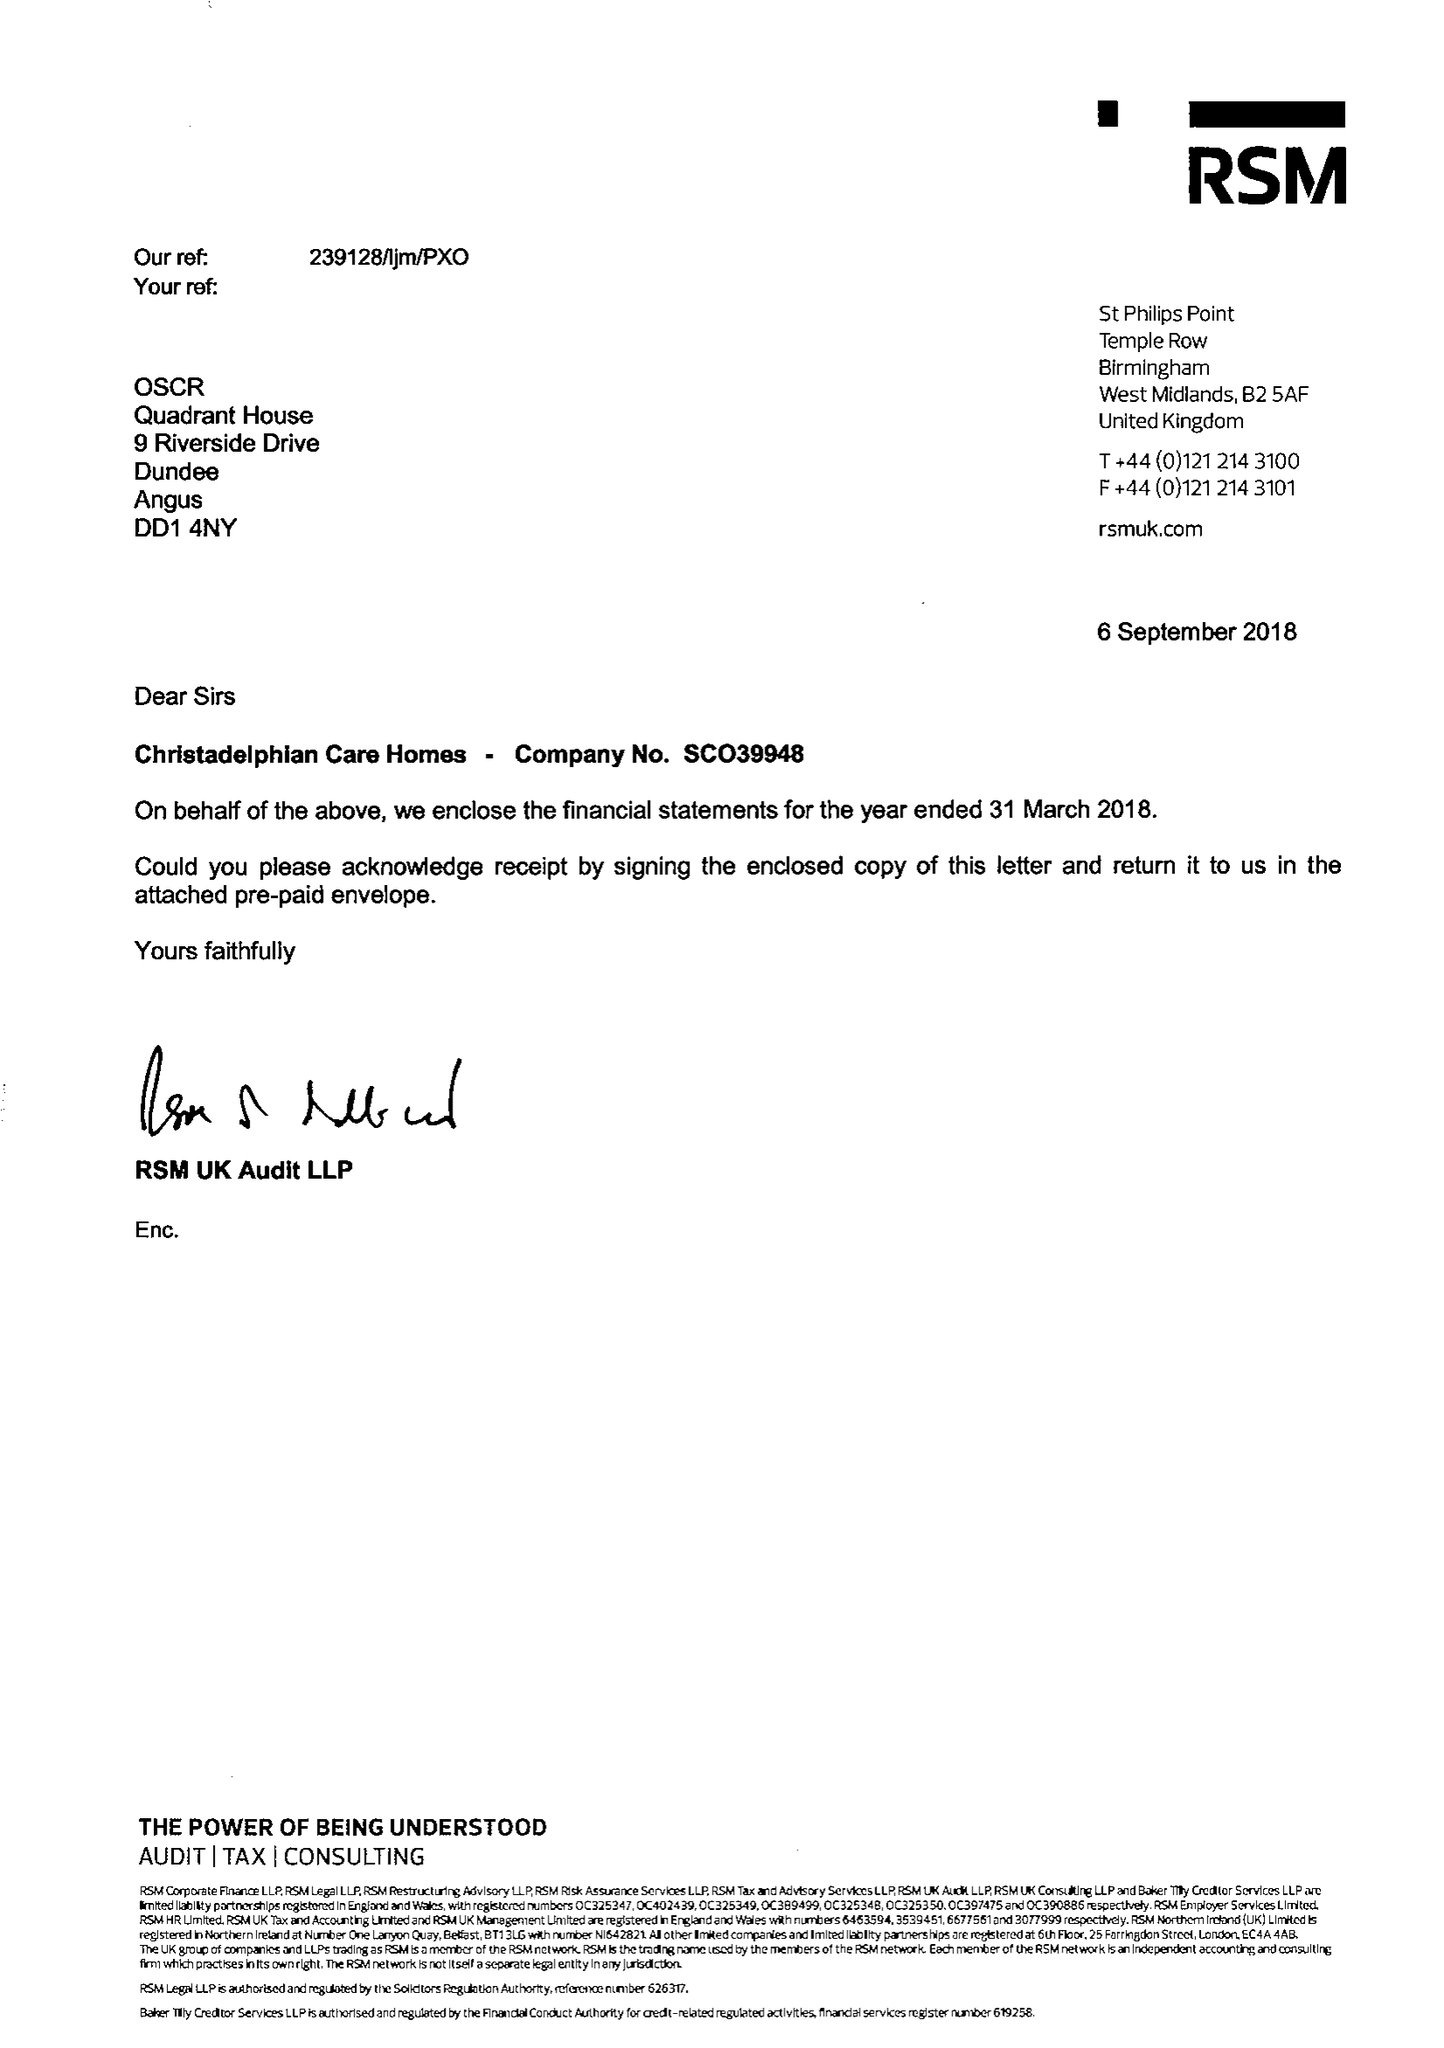What is the value for the report_date?
Answer the question using a single word or phrase. 2018-03-31 